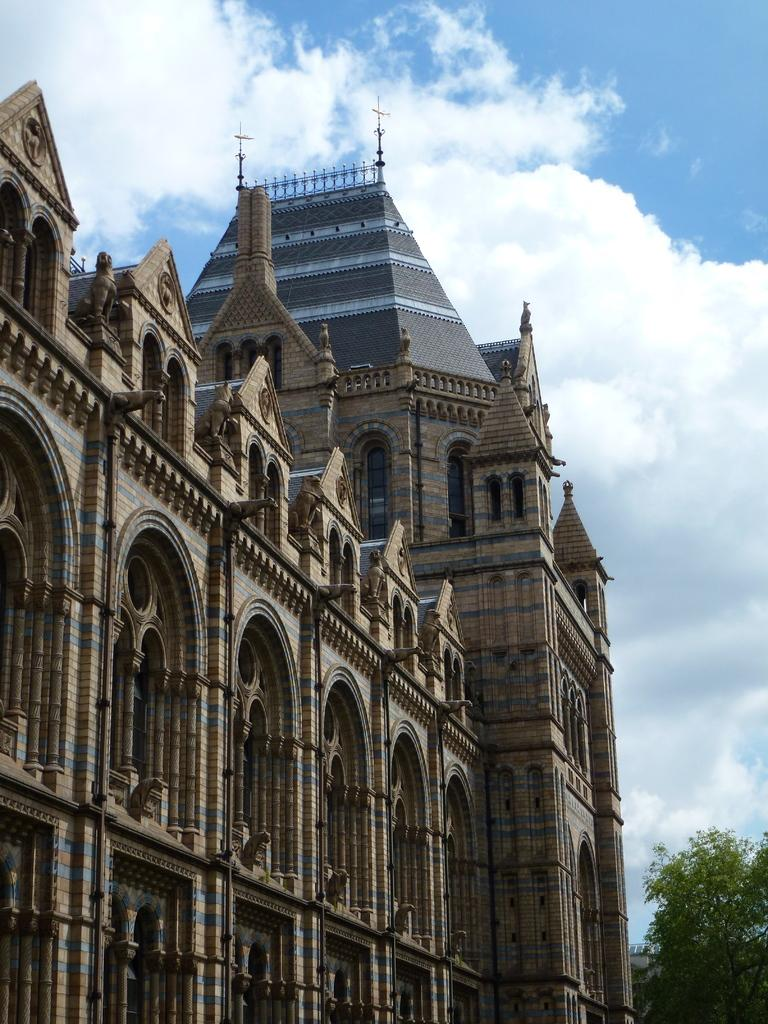What type of structure is present in the image? There is a building in the image. What other natural elements can be seen in the image? There are trees in the image. What is visible in the sky in the image? There are clouds visible in the image. What type of shoe can be seen hanging from the tree in the image? There is no shoe present in the image; it only features a building, trees, and clouds. 